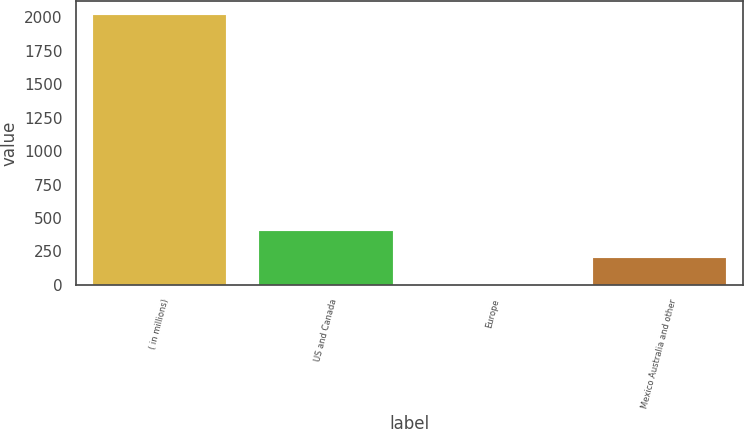<chart> <loc_0><loc_0><loc_500><loc_500><bar_chart><fcel>( in millions)<fcel>US and Canada<fcel>Europe<fcel>Mexico Australia and other<nl><fcel>2017<fcel>404.52<fcel>1.4<fcel>202.96<nl></chart> 